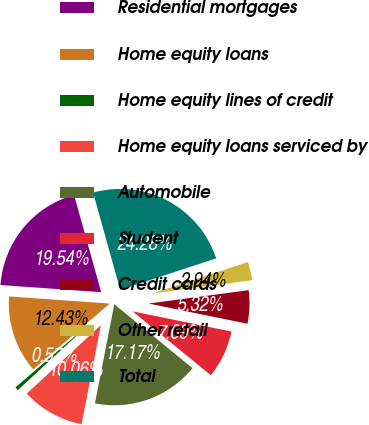<chart> <loc_0><loc_0><loc_500><loc_500><pie_chart><fcel>Residential mortgages<fcel>Home equity loans<fcel>Home equity lines of credit<fcel>Home equity loans serviced by<fcel>Automobile<fcel>Student<fcel>Credit cards<fcel>Other retail<fcel>Total<nl><fcel>19.54%<fcel>12.43%<fcel>0.57%<fcel>10.06%<fcel>17.17%<fcel>7.69%<fcel>5.32%<fcel>2.94%<fcel>24.28%<nl></chart> 